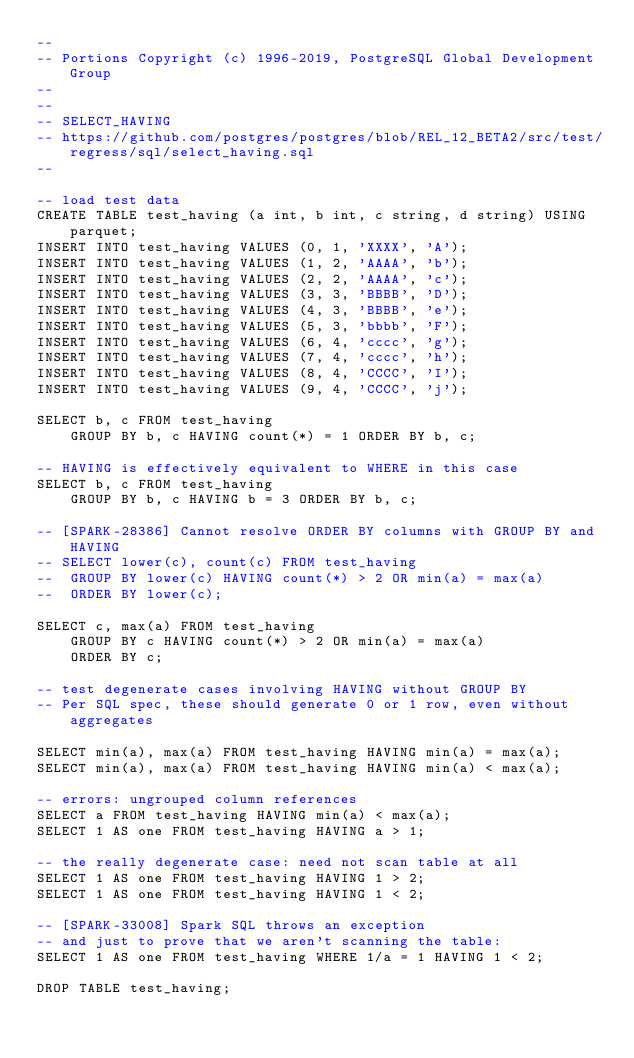Convert code to text. <code><loc_0><loc_0><loc_500><loc_500><_SQL_>--
-- Portions Copyright (c) 1996-2019, PostgreSQL Global Development Group
--
--
-- SELECT_HAVING
-- https://github.com/postgres/postgres/blob/REL_12_BETA2/src/test/regress/sql/select_having.sql
--

-- load test data
CREATE TABLE test_having (a int, b int, c string, d string) USING parquet;
INSERT INTO test_having VALUES (0, 1, 'XXXX', 'A');
INSERT INTO test_having VALUES (1, 2, 'AAAA', 'b');
INSERT INTO test_having VALUES (2, 2, 'AAAA', 'c');
INSERT INTO test_having VALUES (3, 3, 'BBBB', 'D');
INSERT INTO test_having VALUES (4, 3, 'BBBB', 'e');
INSERT INTO test_having VALUES (5, 3, 'bbbb', 'F');
INSERT INTO test_having VALUES (6, 4, 'cccc', 'g');
INSERT INTO test_having VALUES (7, 4, 'cccc', 'h');
INSERT INTO test_having VALUES (8, 4, 'CCCC', 'I');
INSERT INTO test_having VALUES (9, 4, 'CCCC', 'j');

SELECT b, c FROM test_having
	GROUP BY b, c HAVING count(*) = 1 ORDER BY b, c;

-- HAVING is effectively equivalent to WHERE in this case
SELECT b, c FROM test_having
	GROUP BY b, c HAVING b = 3 ORDER BY b, c;

-- [SPARK-28386] Cannot resolve ORDER BY columns with GROUP BY and HAVING
-- SELECT lower(c), count(c) FROM test_having
-- 	GROUP BY lower(c) HAVING count(*) > 2 OR min(a) = max(a)
-- 	ORDER BY lower(c);

SELECT c, max(a) FROM test_having
	GROUP BY c HAVING count(*) > 2 OR min(a) = max(a)
	ORDER BY c;

-- test degenerate cases involving HAVING without GROUP BY
-- Per SQL spec, these should generate 0 or 1 row, even without aggregates

SELECT min(a), max(a) FROM test_having HAVING min(a) = max(a);
SELECT min(a), max(a) FROM test_having HAVING min(a) < max(a);

-- errors: ungrouped column references
SELECT a FROM test_having HAVING min(a) < max(a);
SELECT 1 AS one FROM test_having HAVING a > 1;

-- the really degenerate case: need not scan table at all
SELECT 1 AS one FROM test_having HAVING 1 > 2;
SELECT 1 AS one FROM test_having HAVING 1 < 2;

-- [SPARK-33008] Spark SQL throws an exception
-- and just to prove that we aren't scanning the table:
SELECT 1 AS one FROM test_having WHERE 1/a = 1 HAVING 1 < 2;

DROP TABLE test_having;
</code> 